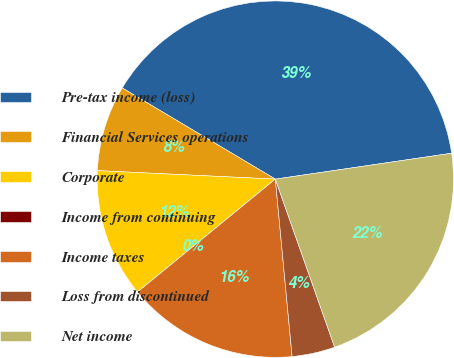Convert chart. <chart><loc_0><loc_0><loc_500><loc_500><pie_chart><fcel>Pre-tax income (loss)<fcel>Financial Services operations<fcel>Corporate<fcel>Income from continuing<fcel>Income taxes<fcel>Loss from discontinued<fcel>Net income<nl><fcel>39.13%<fcel>7.79%<fcel>11.68%<fcel>0.0%<fcel>15.58%<fcel>3.9%<fcel>21.92%<nl></chart> 